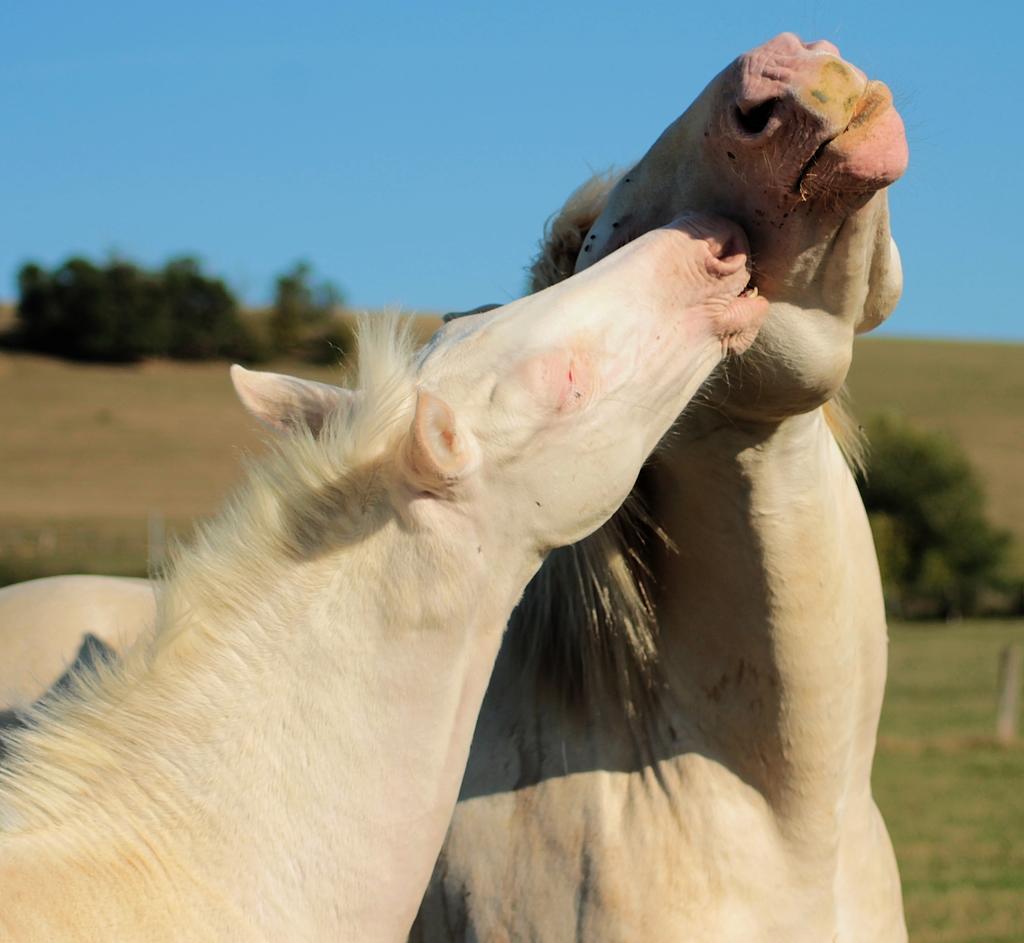Could you give a brief overview of what you see in this image? In this image we can see two horses which are white in color and in the background of the image there are some trees and clear sky. 